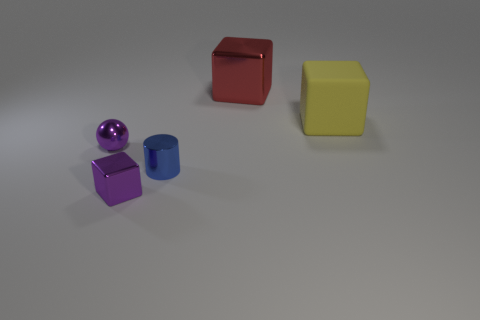Subtract all metal blocks. How many blocks are left? 1 Subtract all yellow blocks. How many blocks are left? 2 Add 3 red shiny cubes. How many objects exist? 8 Subtract 2 blocks. How many blocks are left? 1 Subtract all spheres. How many objects are left? 4 Add 5 rubber blocks. How many rubber blocks exist? 6 Subtract 0 gray cylinders. How many objects are left? 5 Subtract all gray cubes. Subtract all green spheres. How many cubes are left? 3 Subtract all big red metallic blocks. Subtract all yellow matte objects. How many objects are left? 3 Add 3 red shiny cubes. How many red shiny cubes are left? 4 